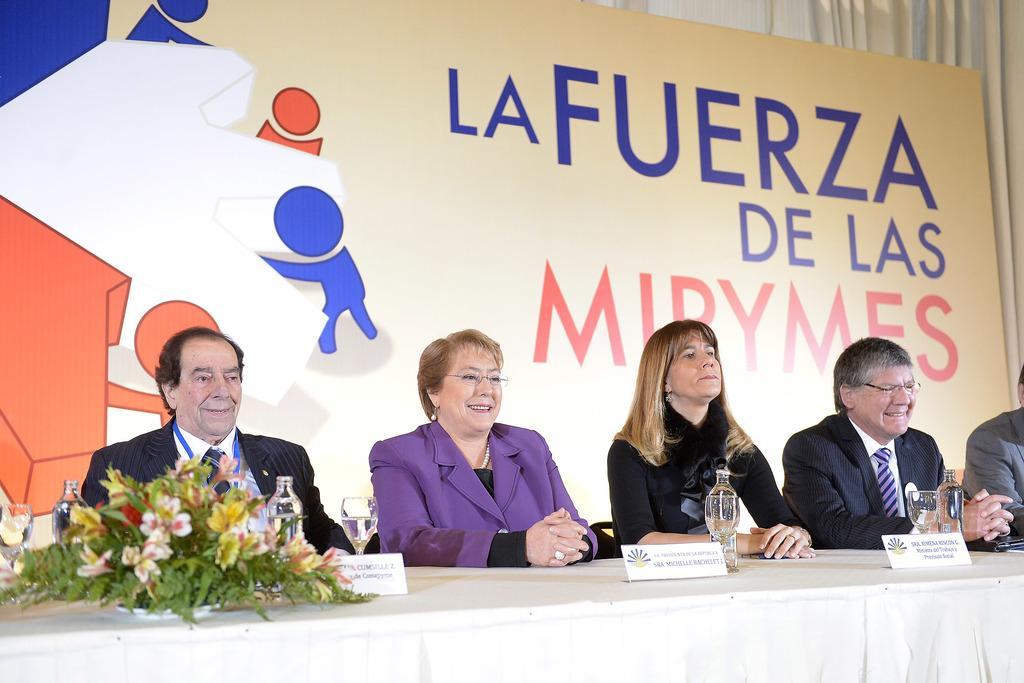Can you describe this image briefly? In this image we can see five persons. In front of the persons we can see few objects on the table. Behind the persons we can see a banner with text and image. On the top right, we can see a curtain. 